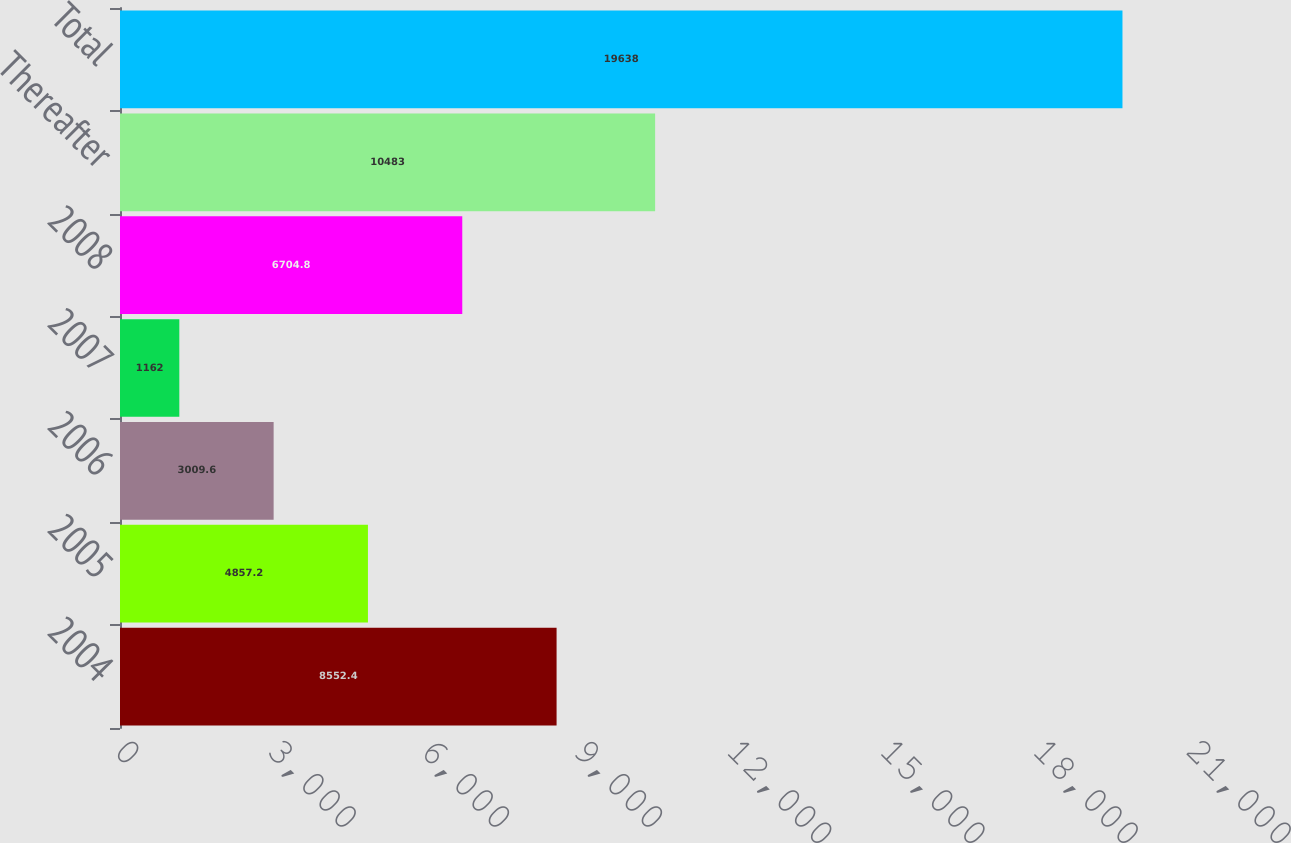<chart> <loc_0><loc_0><loc_500><loc_500><bar_chart><fcel>2004<fcel>2005<fcel>2006<fcel>2007<fcel>2008<fcel>Thereafter<fcel>Total<nl><fcel>8552.4<fcel>4857.2<fcel>3009.6<fcel>1162<fcel>6704.8<fcel>10483<fcel>19638<nl></chart> 